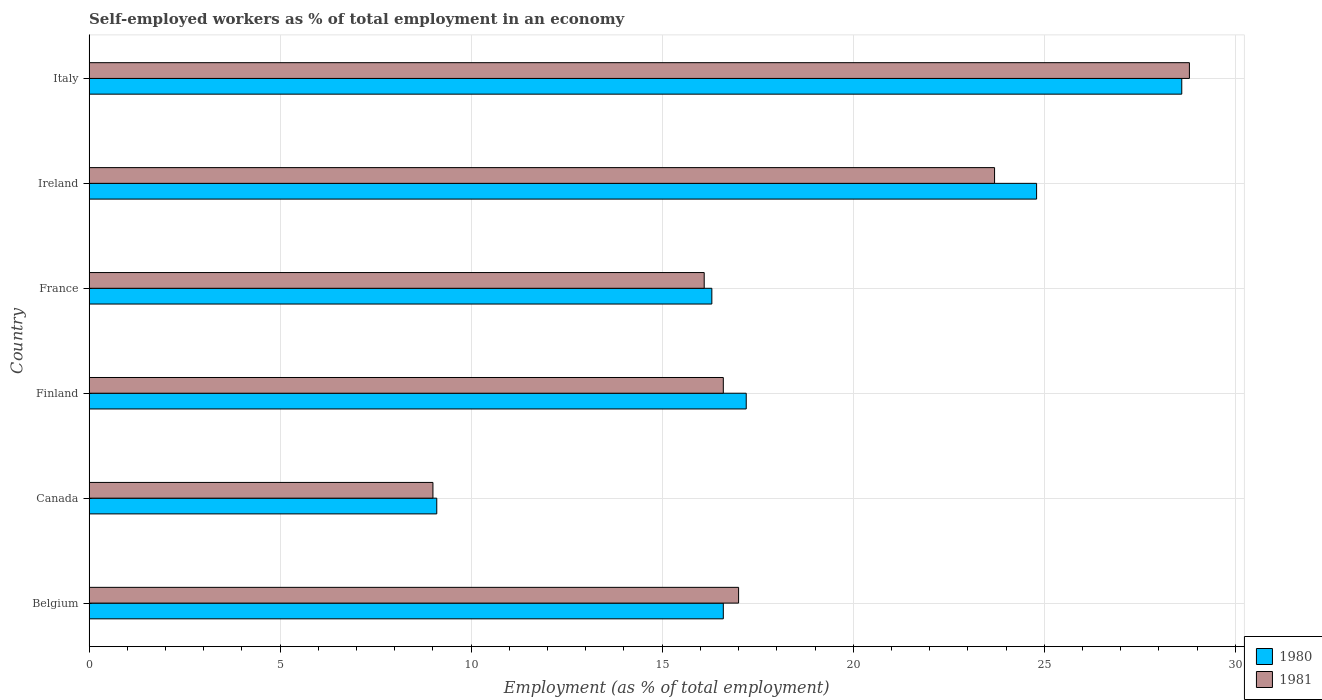How many groups of bars are there?
Offer a terse response. 6. Are the number of bars on each tick of the Y-axis equal?
Offer a terse response. Yes. How many bars are there on the 4th tick from the bottom?
Ensure brevity in your answer.  2. What is the label of the 1st group of bars from the top?
Offer a terse response. Italy. In how many cases, is the number of bars for a given country not equal to the number of legend labels?
Keep it short and to the point. 0. What is the percentage of self-employed workers in 1981 in Ireland?
Offer a very short reply. 23.7. Across all countries, what is the maximum percentage of self-employed workers in 1981?
Make the answer very short. 28.8. Across all countries, what is the minimum percentage of self-employed workers in 1981?
Make the answer very short. 9. In which country was the percentage of self-employed workers in 1981 maximum?
Offer a terse response. Italy. What is the total percentage of self-employed workers in 1981 in the graph?
Make the answer very short. 111.2. What is the difference between the percentage of self-employed workers in 1981 in Belgium and that in Finland?
Ensure brevity in your answer.  0.4. What is the difference between the percentage of self-employed workers in 1981 in Italy and the percentage of self-employed workers in 1980 in Ireland?
Your answer should be very brief. 4. What is the average percentage of self-employed workers in 1981 per country?
Keep it short and to the point. 18.53. What is the difference between the percentage of self-employed workers in 1981 and percentage of self-employed workers in 1980 in Italy?
Your answer should be compact. 0.2. In how many countries, is the percentage of self-employed workers in 1980 greater than 26 %?
Provide a short and direct response. 1. What is the ratio of the percentage of self-employed workers in 1981 in Belgium to that in Canada?
Your answer should be compact. 1.89. What is the difference between the highest and the second highest percentage of self-employed workers in 1980?
Your answer should be compact. 3.8. What is the difference between the highest and the lowest percentage of self-employed workers in 1980?
Ensure brevity in your answer.  19.5. How many countries are there in the graph?
Your answer should be compact. 6. What is the difference between two consecutive major ticks on the X-axis?
Your answer should be compact. 5. Are the values on the major ticks of X-axis written in scientific E-notation?
Offer a terse response. No. Does the graph contain any zero values?
Ensure brevity in your answer.  No. Does the graph contain grids?
Make the answer very short. Yes. Where does the legend appear in the graph?
Your answer should be very brief. Bottom right. What is the title of the graph?
Make the answer very short. Self-employed workers as % of total employment in an economy. Does "1969" appear as one of the legend labels in the graph?
Ensure brevity in your answer.  No. What is the label or title of the X-axis?
Your answer should be very brief. Employment (as % of total employment). What is the label or title of the Y-axis?
Offer a terse response. Country. What is the Employment (as % of total employment) in 1980 in Belgium?
Your answer should be compact. 16.6. What is the Employment (as % of total employment) of 1980 in Canada?
Provide a succinct answer. 9.1. What is the Employment (as % of total employment) in 1981 in Canada?
Offer a very short reply. 9. What is the Employment (as % of total employment) of 1980 in Finland?
Keep it short and to the point. 17.2. What is the Employment (as % of total employment) in 1981 in Finland?
Keep it short and to the point. 16.6. What is the Employment (as % of total employment) of 1980 in France?
Offer a terse response. 16.3. What is the Employment (as % of total employment) in 1981 in France?
Your response must be concise. 16.1. What is the Employment (as % of total employment) of 1980 in Ireland?
Make the answer very short. 24.8. What is the Employment (as % of total employment) in 1981 in Ireland?
Your answer should be very brief. 23.7. What is the Employment (as % of total employment) in 1980 in Italy?
Your answer should be compact. 28.6. What is the Employment (as % of total employment) in 1981 in Italy?
Make the answer very short. 28.8. Across all countries, what is the maximum Employment (as % of total employment) of 1980?
Provide a succinct answer. 28.6. Across all countries, what is the maximum Employment (as % of total employment) of 1981?
Provide a succinct answer. 28.8. Across all countries, what is the minimum Employment (as % of total employment) of 1980?
Keep it short and to the point. 9.1. Across all countries, what is the minimum Employment (as % of total employment) of 1981?
Offer a very short reply. 9. What is the total Employment (as % of total employment) in 1980 in the graph?
Provide a succinct answer. 112.6. What is the total Employment (as % of total employment) in 1981 in the graph?
Your answer should be compact. 111.2. What is the difference between the Employment (as % of total employment) in 1980 in Belgium and that in France?
Provide a succinct answer. 0.3. What is the difference between the Employment (as % of total employment) in 1980 in Belgium and that in Ireland?
Give a very brief answer. -8.2. What is the difference between the Employment (as % of total employment) of 1980 in Belgium and that in Italy?
Provide a succinct answer. -12. What is the difference between the Employment (as % of total employment) of 1981 in Belgium and that in Italy?
Offer a very short reply. -11.8. What is the difference between the Employment (as % of total employment) in 1980 in Canada and that in France?
Give a very brief answer. -7.2. What is the difference between the Employment (as % of total employment) of 1981 in Canada and that in France?
Your answer should be compact. -7.1. What is the difference between the Employment (as % of total employment) of 1980 in Canada and that in Ireland?
Provide a succinct answer. -15.7. What is the difference between the Employment (as % of total employment) in 1981 in Canada and that in Ireland?
Give a very brief answer. -14.7. What is the difference between the Employment (as % of total employment) in 1980 in Canada and that in Italy?
Your answer should be compact. -19.5. What is the difference between the Employment (as % of total employment) of 1981 in Canada and that in Italy?
Make the answer very short. -19.8. What is the difference between the Employment (as % of total employment) in 1981 in Finland and that in France?
Ensure brevity in your answer.  0.5. What is the difference between the Employment (as % of total employment) in 1980 in Finland and that in Ireland?
Offer a very short reply. -7.6. What is the difference between the Employment (as % of total employment) of 1981 in Finland and that in Italy?
Your response must be concise. -12.2. What is the difference between the Employment (as % of total employment) of 1980 in France and that in Ireland?
Give a very brief answer. -8.5. What is the difference between the Employment (as % of total employment) in 1981 in France and that in Ireland?
Your answer should be compact. -7.6. What is the difference between the Employment (as % of total employment) of 1980 in France and that in Italy?
Provide a short and direct response. -12.3. What is the difference between the Employment (as % of total employment) in 1980 in Ireland and that in Italy?
Offer a very short reply. -3.8. What is the difference between the Employment (as % of total employment) in 1981 in Ireland and that in Italy?
Keep it short and to the point. -5.1. What is the difference between the Employment (as % of total employment) of 1980 in Belgium and the Employment (as % of total employment) of 1981 in Canada?
Offer a terse response. 7.6. What is the difference between the Employment (as % of total employment) of 1980 in Belgium and the Employment (as % of total employment) of 1981 in Finland?
Make the answer very short. 0. What is the difference between the Employment (as % of total employment) in 1980 in Belgium and the Employment (as % of total employment) in 1981 in Ireland?
Offer a very short reply. -7.1. What is the difference between the Employment (as % of total employment) of 1980 in Canada and the Employment (as % of total employment) of 1981 in France?
Ensure brevity in your answer.  -7. What is the difference between the Employment (as % of total employment) in 1980 in Canada and the Employment (as % of total employment) in 1981 in Ireland?
Give a very brief answer. -14.6. What is the difference between the Employment (as % of total employment) of 1980 in Canada and the Employment (as % of total employment) of 1981 in Italy?
Offer a terse response. -19.7. What is the difference between the Employment (as % of total employment) in 1980 in Finland and the Employment (as % of total employment) in 1981 in France?
Offer a terse response. 1.1. What is the difference between the Employment (as % of total employment) of 1980 in Finland and the Employment (as % of total employment) of 1981 in Italy?
Offer a very short reply. -11.6. What is the difference between the Employment (as % of total employment) in 1980 in France and the Employment (as % of total employment) in 1981 in Italy?
Keep it short and to the point. -12.5. What is the difference between the Employment (as % of total employment) in 1980 in Ireland and the Employment (as % of total employment) in 1981 in Italy?
Make the answer very short. -4. What is the average Employment (as % of total employment) in 1980 per country?
Your answer should be very brief. 18.77. What is the average Employment (as % of total employment) in 1981 per country?
Offer a terse response. 18.53. What is the difference between the Employment (as % of total employment) in 1980 and Employment (as % of total employment) in 1981 in Belgium?
Ensure brevity in your answer.  -0.4. What is the difference between the Employment (as % of total employment) of 1980 and Employment (as % of total employment) of 1981 in Canada?
Your response must be concise. 0.1. What is the difference between the Employment (as % of total employment) of 1980 and Employment (as % of total employment) of 1981 in Finland?
Provide a short and direct response. 0.6. What is the difference between the Employment (as % of total employment) in 1980 and Employment (as % of total employment) in 1981 in Ireland?
Your answer should be very brief. 1.1. What is the ratio of the Employment (as % of total employment) in 1980 in Belgium to that in Canada?
Offer a terse response. 1.82. What is the ratio of the Employment (as % of total employment) in 1981 in Belgium to that in Canada?
Offer a terse response. 1.89. What is the ratio of the Employment (as % of total employment) in 1980 in Belgium to that in Finland?
Offer a terse response. 0.97. What is the ratio of the Employment (as % of total employment) in 1981 in Belgium to that in Finland?
Offer a very short reply. 1.02. What is the ratio of the Employment (as % of total employment) of 1980 in Belgium to that in France?
Make the answer very short. 1.02. What is the ratio of the Employment (as % of total employment) in 1981 in Belgium to that in France?
Keep it short and to the point. 1.06. What is the ratio of the Employment (as % of total employment) of 1980 in Belgium to that in Ireland?
Provide a succinct answer. 0.67. What is the ratio of the Employment (as % of total employment) in 1981 in Belgium to that in Ireland?
Give a very brief answer. 0.72. What is the ratio of the Employment (as % of total employment) in 1980 in Belgium to that in Italy?
Keep it short and to the point. 0.58. What is the ratio of the Employment (as % of total employment) of 1981 in Belgium to that in Italy?
Offer a terse response. 0.59. What is the ratio of the Employment (as % of total employment) of 1980 in Canada to that in Finland?
Provide a short and direct response. 0.53. What is the ratio of the Employment (as % of total employment) in 1981 in Canada to that in Finland?
Your response must be concise. 0.54. What is the ratio of the Employment (as % of total employment) in 1980 in Canada to that in France?
Offer a terse response. 0.56. What is the ratio of the Employment (as % of total employment) in 1981 in Canada to that in France?
Your answer should be very brief. 0.56. What is the ratio of the Employment (as % of total employment) in 1980 in Canada to that in Ireland?
Ensure brevity in your answer.  0.37. What is the ratio of the Employment (as % of total employment) in 1981 in Canada to that in Ireland?
Give a very brief answer. 0.38. What is the ratio of the Employment (as % of total employment) in 1980 in Canada to that in Italy?
Provide a short and direct response. 0.32. What is the ratio of the Employment (as % of total employment) in 1981 in Canada to that in Italy?
Provide a short and direct response. 0.31. What is the ratio of the Employment (as % of total employment) of 1980 in Finland to that in France?
Your response must be concise. 1.06. What is the ratio of the Employment (as % of total employment) in 1981 in Finland to that in France?
Make the answer very short. 1.03. What is the ratio of the Employment (as % of total employment) of 1980 in Finland to that in Ireland?
Your response must be concise. 0.69. What is the ratio of the Employment (as % of total employment) of 1981 in Finland to that in Ireland?
Provide a succinct answer. 0.7. What is the ratio of the Employment (as % of total employment) in 1980 in Finland to that in Italy?
Provide a short and direct response. 0.6. What is the ratio of the Employment (as % of total employment) of 1981 in Finland to that in Italy?
Offer a terse response. 0.58. What is the ratio of the Employment (as % of total employment) in 1980 in France to that in Ireland?
Offer a very short reply. 0.66. What is the ratio of the Employment (as % of total employment) in 1981 in France to that in Ireland?
Your answer should be compact. 0.68. What is the ratio of the Employment (as % of total employment) of 1980 in France to that in Italy?
Ensure brevity in your answer.  0.57. What is the ratio of the Employment (as % of total employment) of 1981 in France to that in Italy?
Your answer should be compact. 0.56. What is the ratio of the Employment (as % of total employment) in 1980 in Ireland to that in Italy?
Make the answer very short. 0.87. What is the ratio of the Employment (as % of total employment) in 1981 in Ireland to that in Italy?
Give a very brief answer. 0.82. What is the difference between the highest and the lowest Employment (as % of total employment) of 1981?
Offer a very short reply. 19.8. 